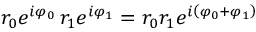<formula> <loc_0><loc_0><loc_500><loc_500>r _ { 0 } e ^ { i \varphi _ { 0 } } \, r _ { 1 } e ^ { i \varphi _ { 1 } } = r _ { 0 } r _ { 1 } e ^ { i \left ( \varphi _ { 0 } + \varphi _ { 1 } \right ) }</formula> 